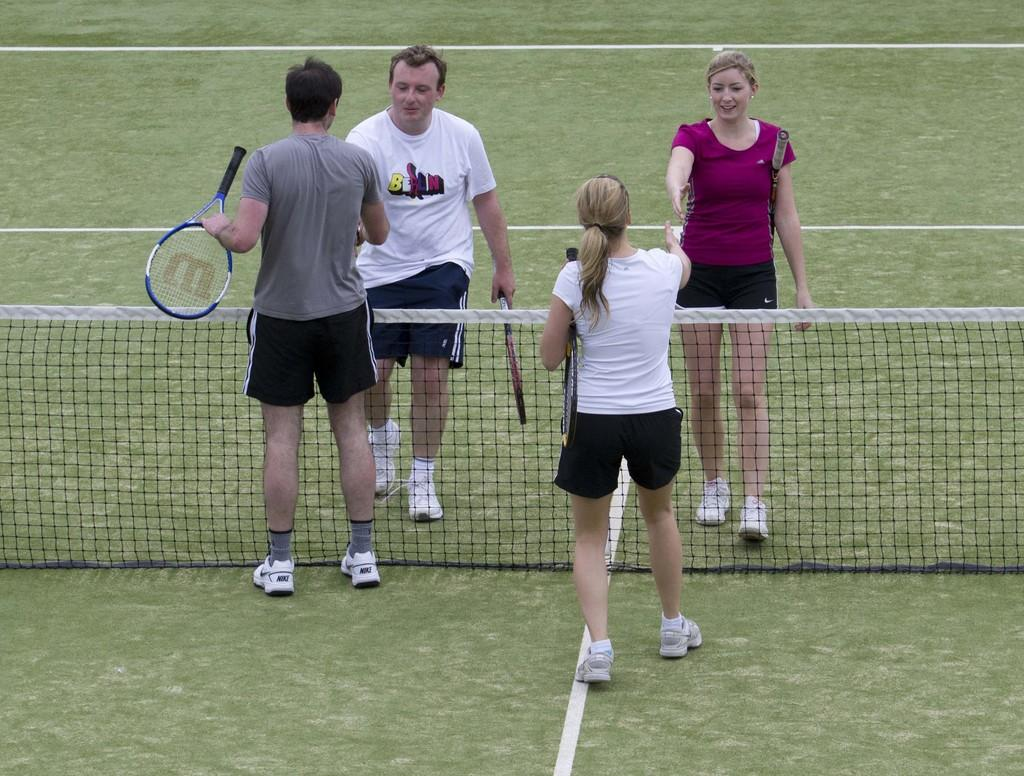How many people are in the image? There are persons standing in the image. What is separating the persons in the image? There is a net between the persons. What object is the man holding in the image? The man is holding a shuttle. What type of joke is being told by the person on the left in the image? There is no indication of a joke being told in the image; the focus is on the persons, the net, and the shuttle. 